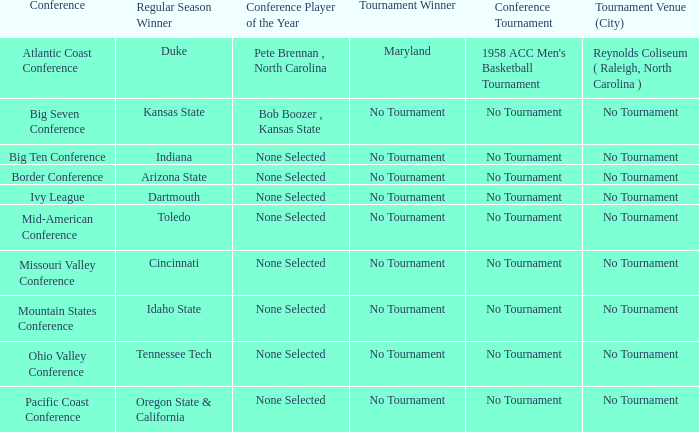Who won the regular season when Missouri Valley Conference took place? Cincinnati. 